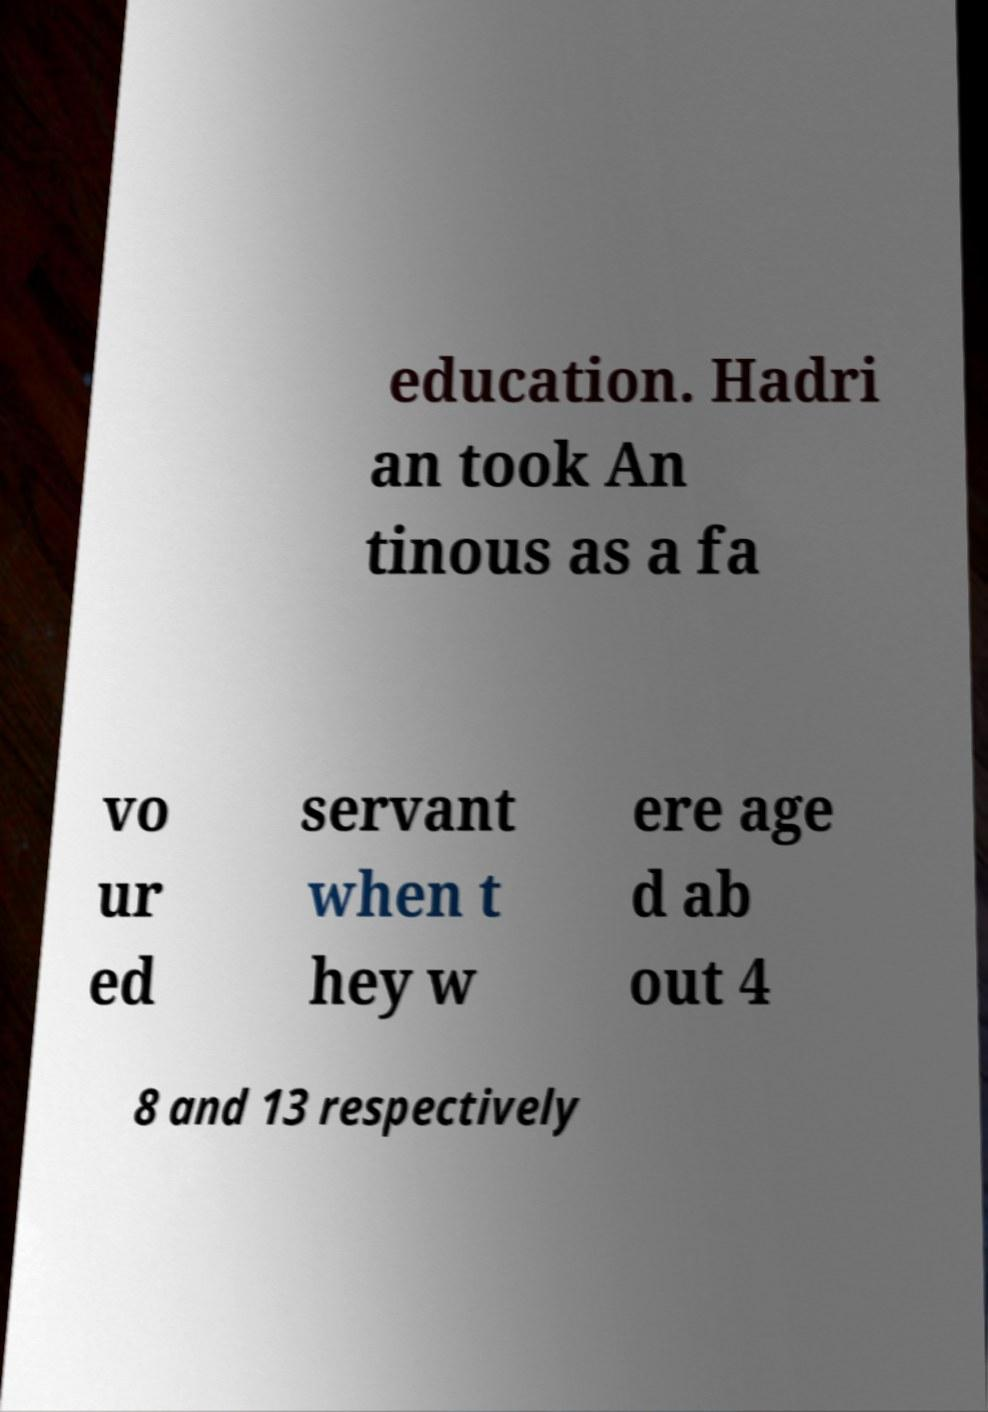What messages or text are displayed in this image? I need them in a readable, typed format. education. Hadri an took An tinous as a fa vo ur ed servant when t hey w ere age d ab out 4 8 and 13 respectively 